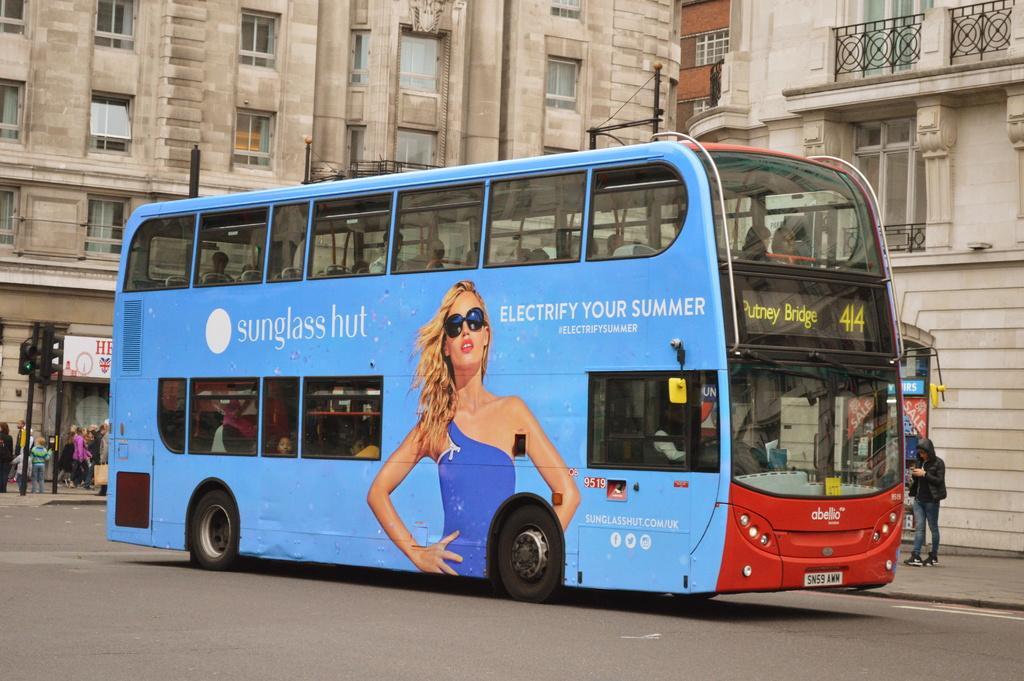In one or two sentences, can you explain what this image depicts? There is a blue color Double-Decker bus on which there is a woman´s image on the road. In the background, there are persons standing on the road, there is a person standing on a footpath, there are buildings which are having glass windows and there are signal lights attached to the poles. 